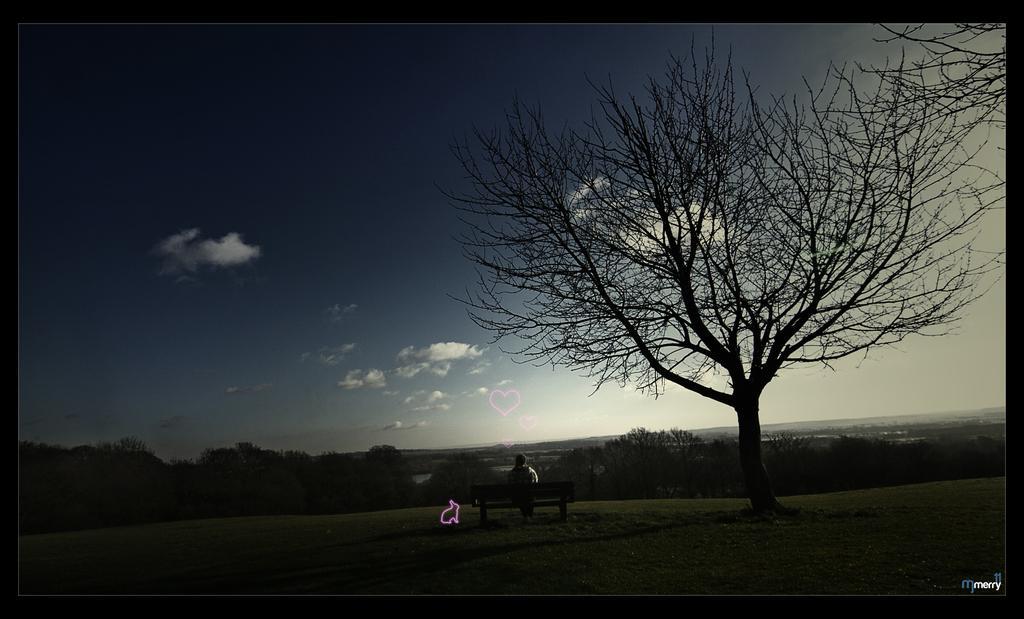How would you summarize this image in a sentence or two? In this picture there is a man who is sitting on the bench. In the background I can see the trees, plants, water and grass. At the top I can see the sky and clouds. In the bottom right corner there is a watermark. 